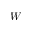<formula> <loc_0><loc_0><loc_500><loc_500>W</formula> 